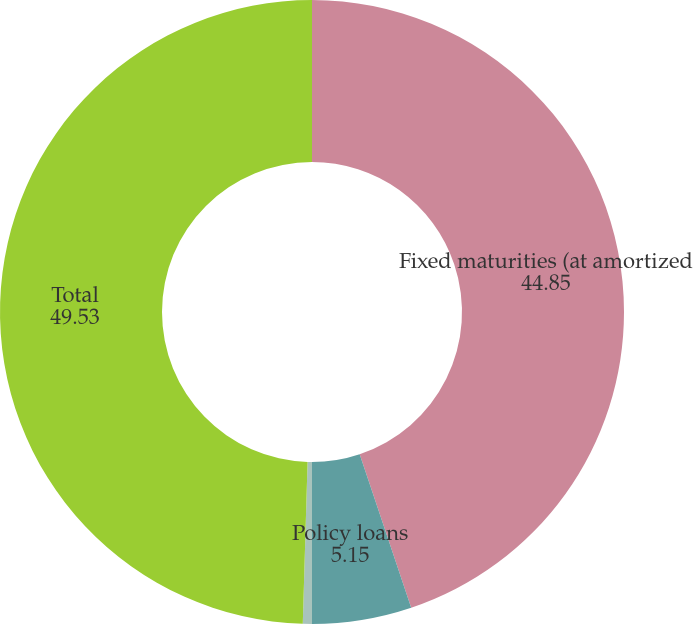<chart> <loc_0><loc_0><loc_500><loc_500><pie_chart><fcel>Fixed maturities (at amortized<fcel>Policy loans<fcel>Short-term investments<fcel>Total<nl><fcel>44.85%<fcel>5.15%<fcel>0.47%<fcel>49.53%<nl></chart> 